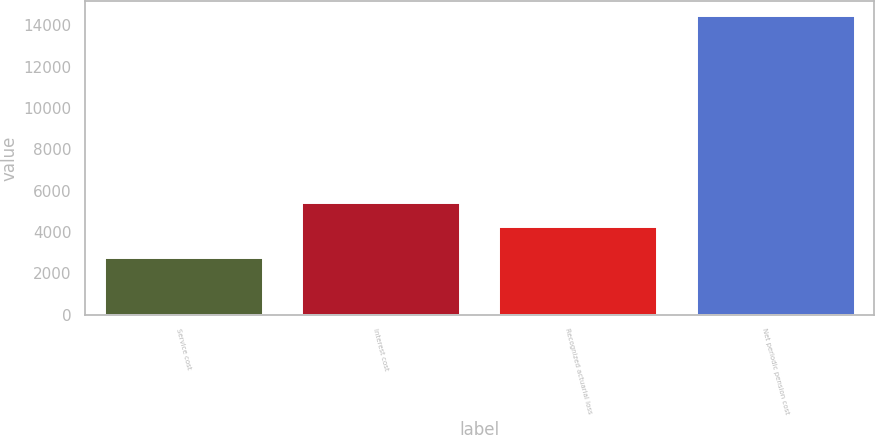<chart> <loc_0><loc_0><loc_500><loc_500><bar_chart><fcel>Service cost<fcel>Interest cost<fcel>Recognized actuarial loss<fcel>Net periodic pension cost<nl><fcel>2756<fcel>5419<fcel>4251<fcel>14436<nl></chart> 